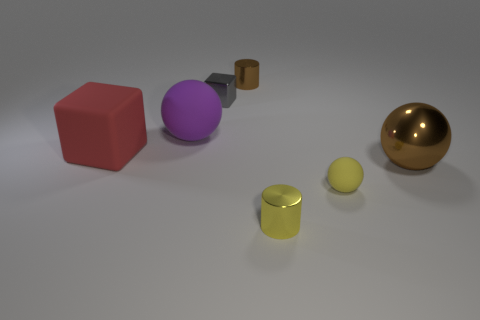What number of matte things are red blocks or purple objects?
Keep it short and to the point. 2. There is a tiny object that is right of the gray metallic thing and behind the big brown thing; what is it made of?
Provide a succinct answer. Metal. Do the large red object and the small block have the same material?
Offer a very short reply. No. There is a matte thing that is both behind the large metal sphere and on the right side of the big rubber cube; what is its size?
Give a very brief answer. Large. What is the shape of the tiny yellow metal object?
Provide a short and direct response. Cylinder. What number of things are either brown things or big things that are on the right side of the gray block?
Make the answer very short. 2. There is a cylinder that is in front of the large brown object; is it the same color as the tiny matte ball?
Provide a succinct answer. Yes. What is the color of the metallic thing that is both in front of the gray object and on the left side of the large brown sphere?
Provide a succinct answer. Yellow. There is a large object to the right of the yellow matte ball; what is its material?
Make the answer very short. Metal. The gray shiny object has what size?
Offer a very short reply. Small. 